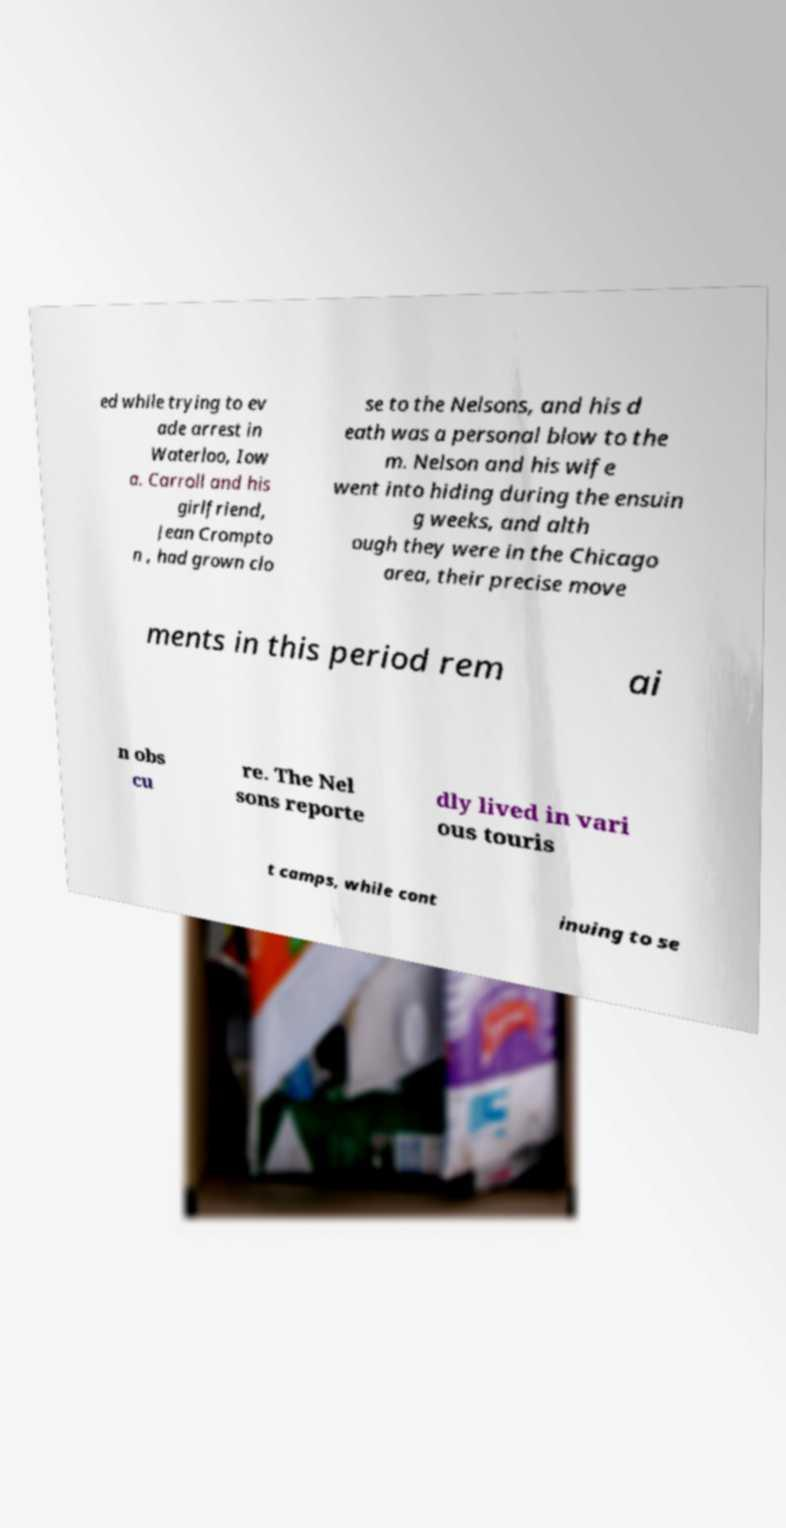Could you assist in decoding the text presented in this image and type it out clearly? ed while trying to ev ade arrest in Waterloo, Iow a. Carroll and his girlfriend, Jean Crompto n , had grown clo se to the Nelsons, and his d eath was a personal blow to the m. Nelson and his wife went into hiding during the ensuin g weeks, and alth ough they were in the Chicago area, their precise move ments in this period rem ai n obs cu re. The Nel sons reporte dly lived in vari ous touris t camps, while cont inuing to se 